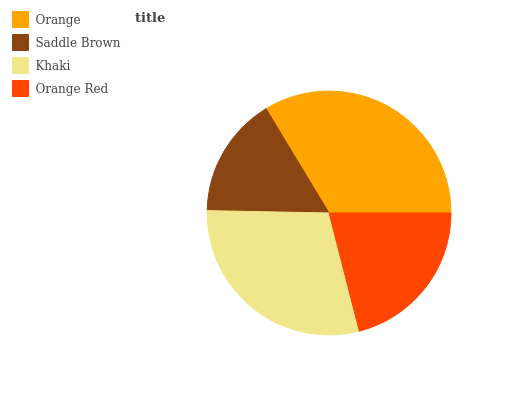Is Saddle Brown the minimum?
Answer yes or no. Yes. Is Orange the maximum?
Answer yes or no. Yes. Is Khaki the minimum?
Answer yes or no. No. Is Khaki the maximum?
Answer yes or no. No. Is Khaki greater than Saddle Brown?
Answer yes or no. Yes. Is Saddle Brown less than Khaki?
Answer yes or no. Yes. Is Saddle Brown greater than Khaki?
Answer yes or no. No. Is Khaki less than Saddle Brown?
Answer yes or no. No. Is Khaki the high median?
Answer yes or no. Yes. Is Orange Red the low median?
Answer yes or no. Yes. Is Orange Red the high median?
Answer yes or no. No. Is Orange the low median?
Answer yes or no. No. 